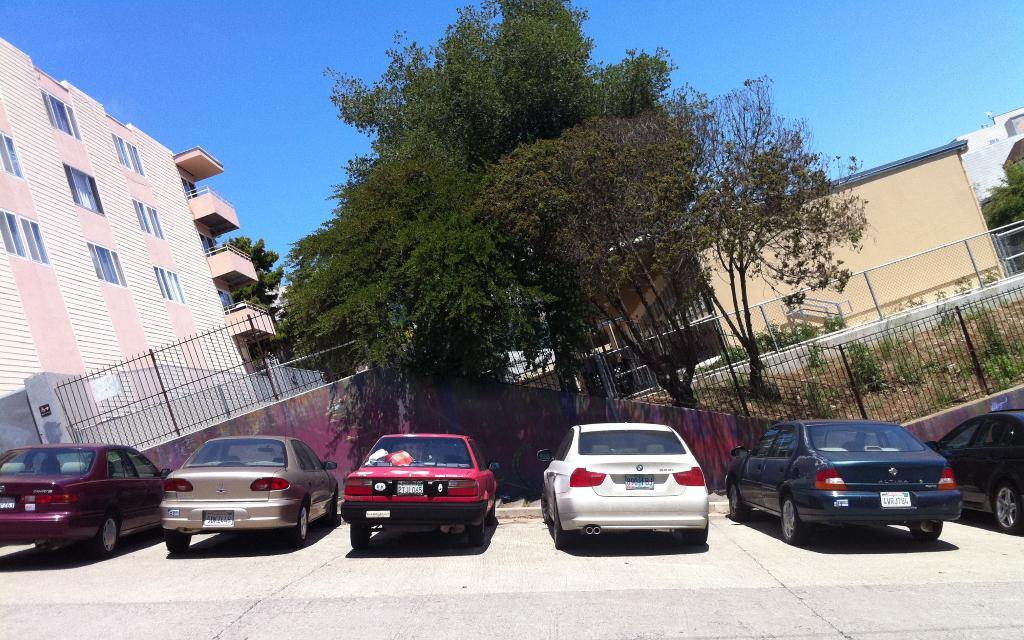What type of structures can be seen in the image? There are buildings in the image. What other natural elements are present in the image? There are trees and plants in the image. Are there any man-made barriers visible in the image? Yes, there are fences in the image. What else can be seen on the ground in the image? There are boards in the image. What type of transportation is visible on the road in the image? There are vehicles on the road in the image. What is visible at the top of the image? The sky is visible at the top of the image. How many buttons can be seen on the trees in the image? There are no buttons present on the trees in the image. What is the fifth element in the image? The provided facts do not mention a fifth element in the image. 